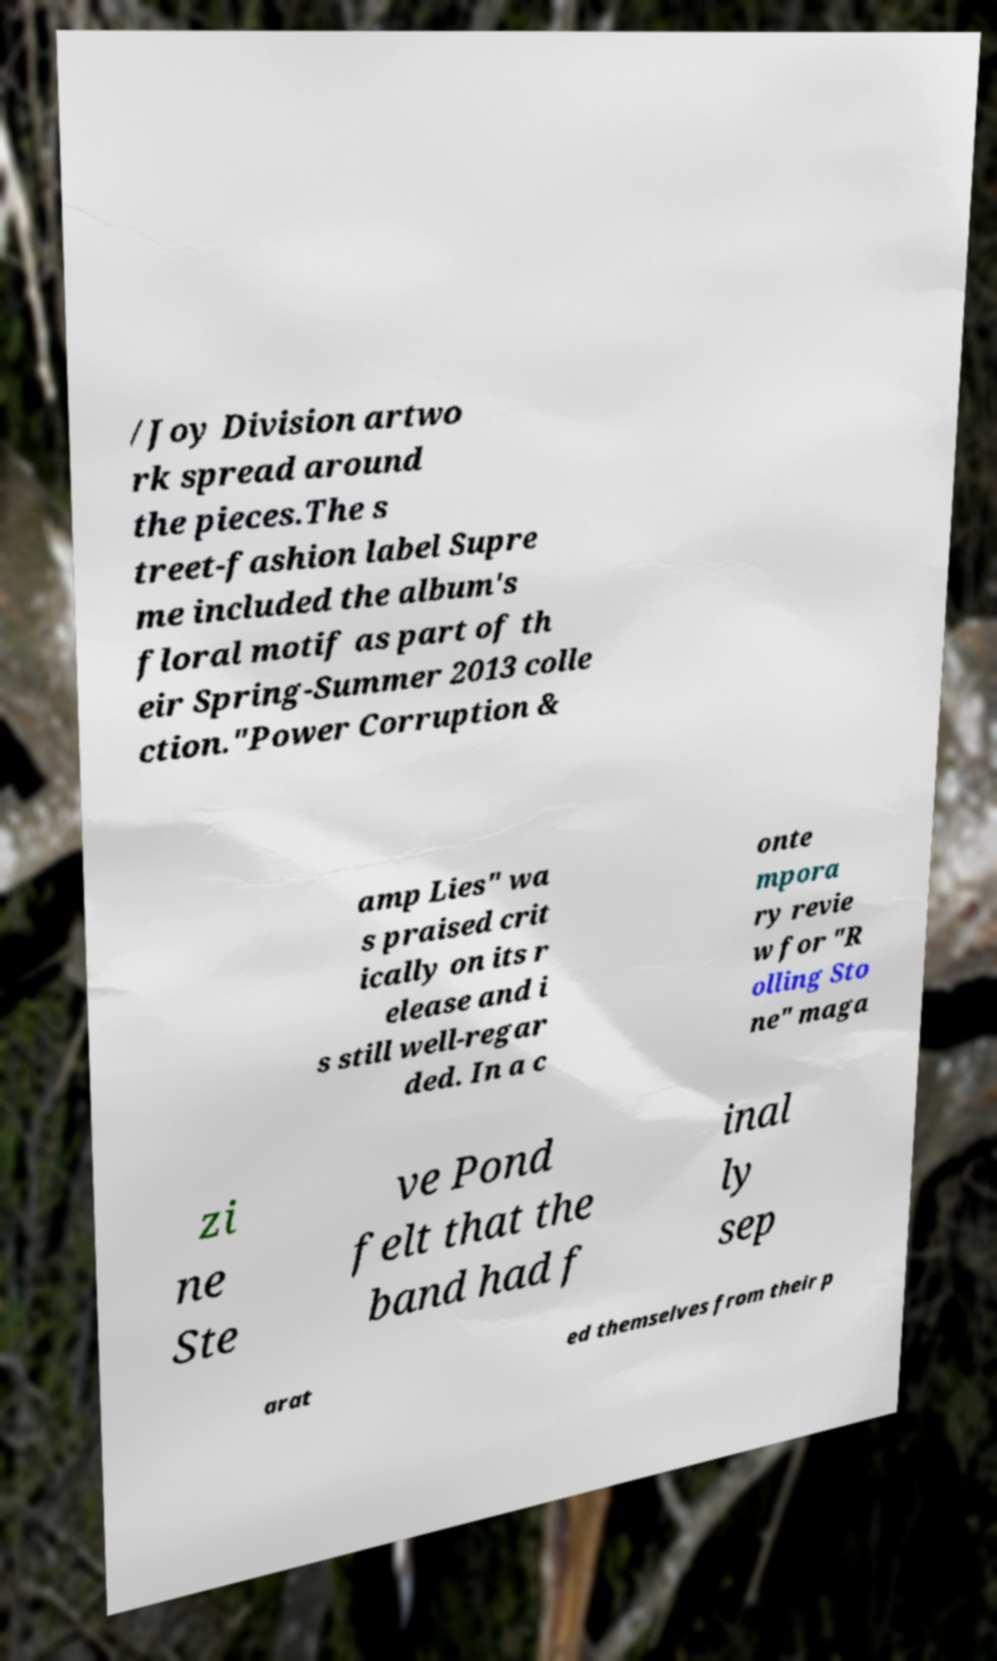Can you accurately transcribe the text from the provided image for me? /Joy Division artwo rk spread around the pieces.The s treet-fashion label Supre me included the album's floral motif as part of th eir Spring-Summer 2013 colle ction."Power Corruption & amp Lies" wa s praised crit ically on its r elease and i s still well-regar ded. In a c onte mpora ry revie w for "R olling Sto ne" maga zi ne Ste ve Pond felt that the band had f inal ly sep arat ed themselves from their p 